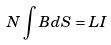<formula> <loc_0><loc_0><loc_500><loc_500>N \int B d S = L I</formula> 